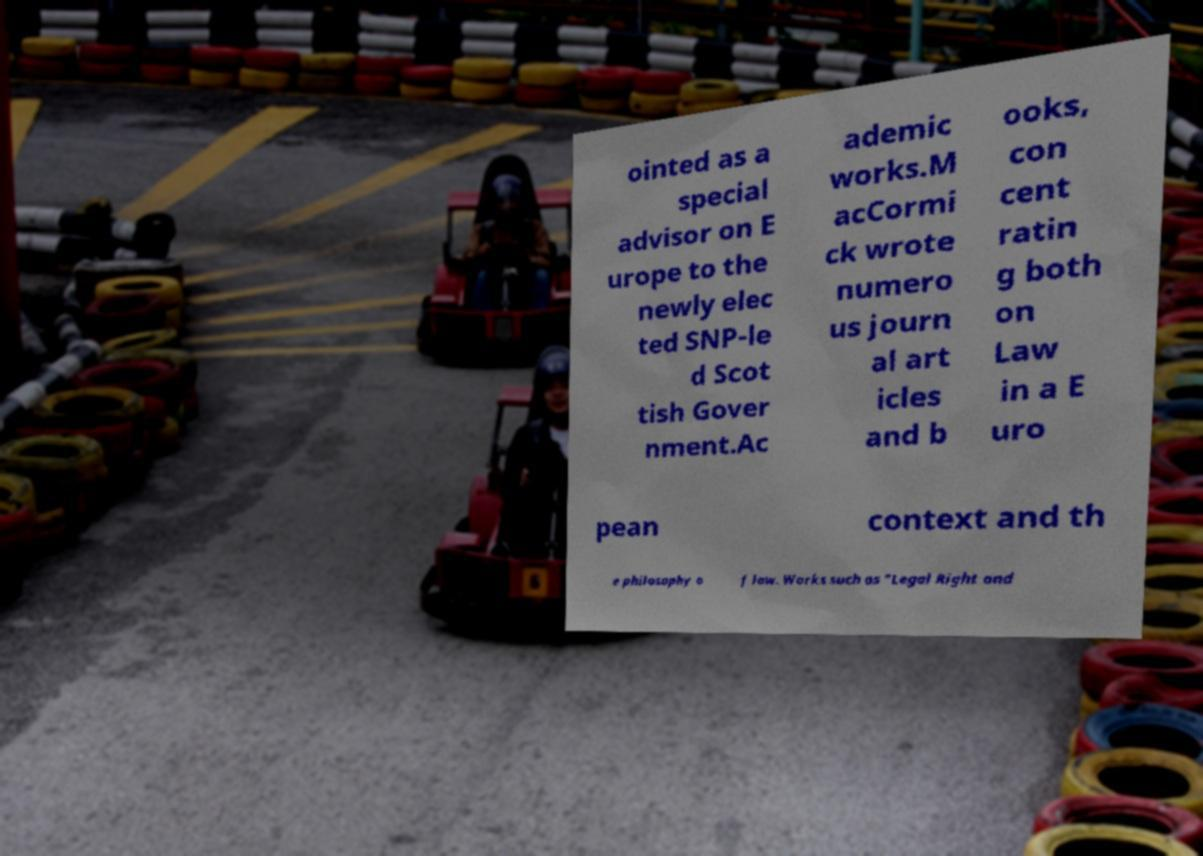Please read and relay the text visible in this image. What does it say? ointed as a special advisor on E urope to the newly elec ted SNP-le d Scot tish Gover nment.Ac ademic works.M acCormi ck wrote numero us journ al art icles and b ooks, con cent ratin g both on Law in a E uro pean context and th e philosophy o f law. Works such as "Legal Right and 